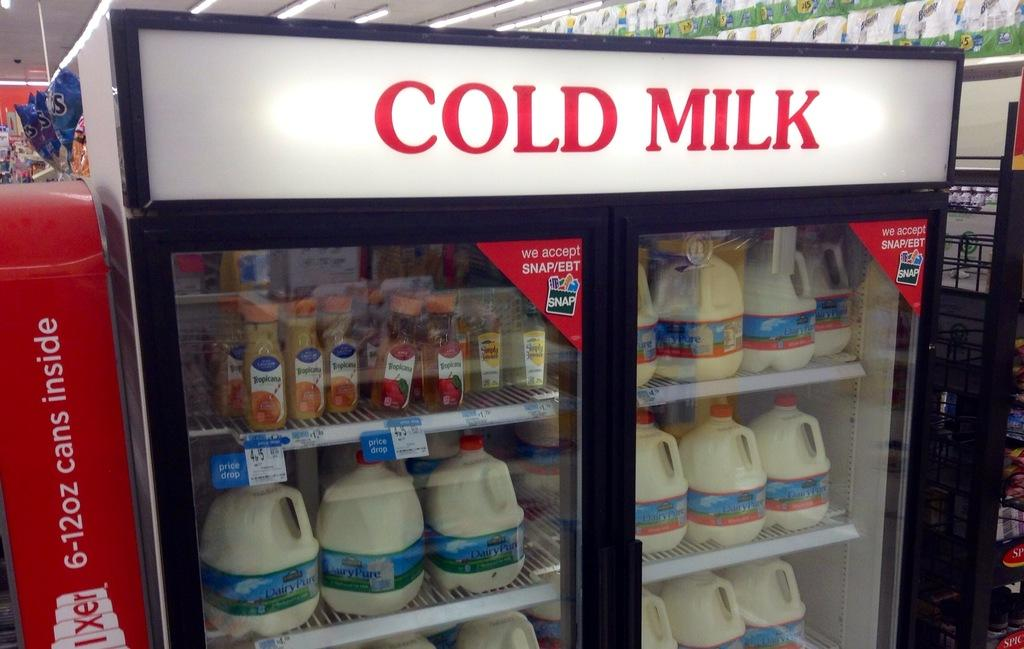<image>
Describe the image concisely. a refrigerator in a store that is labeled 'cold milk' in red 